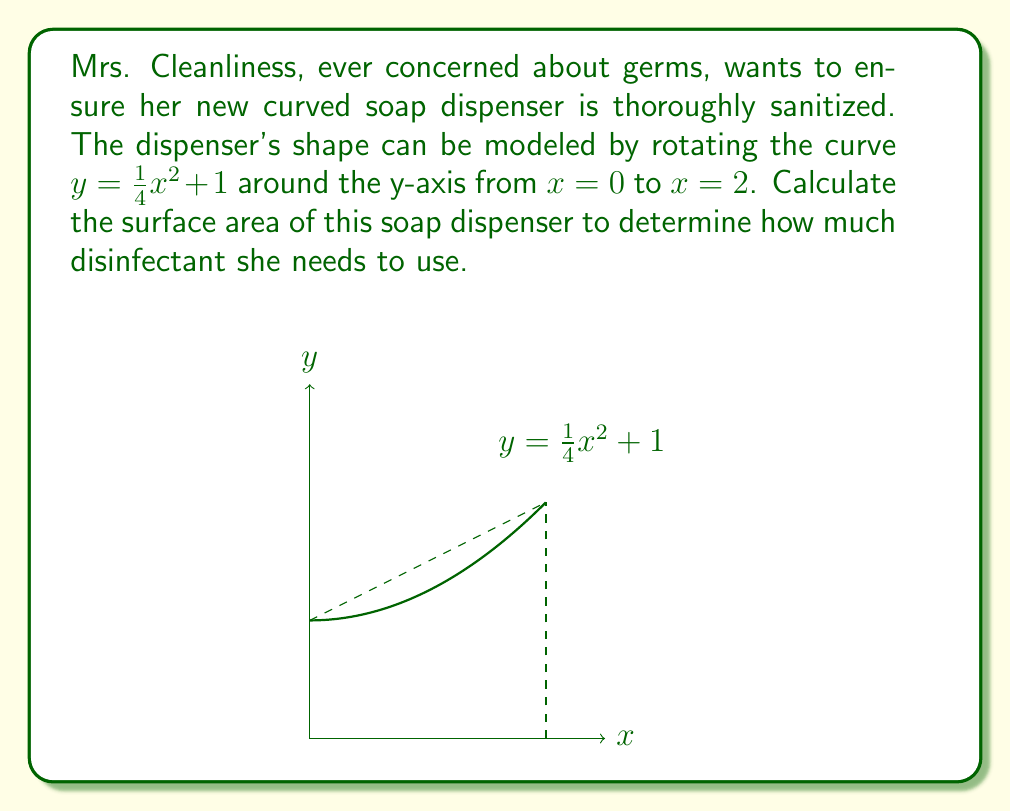Can you answer this question? To calculate the surface area of the curved soap dispenser, we'll use the formula for the surface area of a solid of revolution:

$$S = 2\pi \int_a^b f(x)\sqrt{1 + [f'(x)]^2} dx$$

where $f(x) = \frac{1}{4}x^2 + 1$ and $a = 0$, $b = 2$.

Step 1: Find $f'(x)$
$$f'(x) = \frac{1}{2}x$$

Step 2: Set up the integral
$$S = 2\pi \int_0^2 (\frac{1}{4}x^2 + 1)\sqrt{1 + (\frac{1}{2}x)^2} dx$$

Step 3: Simplify the integrand
$$S = 2\pi \int_0^2 (\frac{1}{4}x^2 + 1)\sqrt{1 + \frac{1}{4}x^2} dx$$

Step 4: This integral is quite complex and doesn't have an elementary antiderivative. We'll need to use numerical integration methods to approximate the result. Using a computer algebra system or numerical integration calculator, we get:

$$S \approx 2\pi(1.80917) \approx 11.3696$$

Step 5: Round to two decimal places for practical use.
Answer: $11.37 \text{ square units}$ 